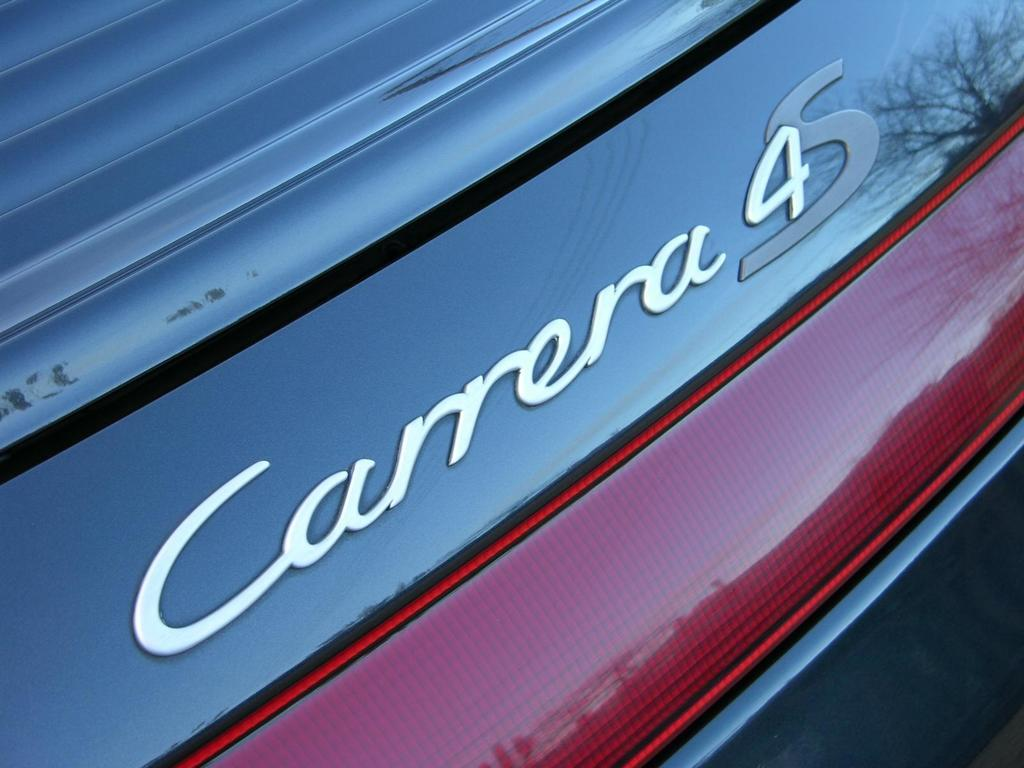What is present on the vehicle in the image? There is text on a vehicle in the image. Can you see a dog playing with a piece of wood near the vehicle in the image? There is no dog or piece of wood present in the image; it only features a vehicle with text on it. 